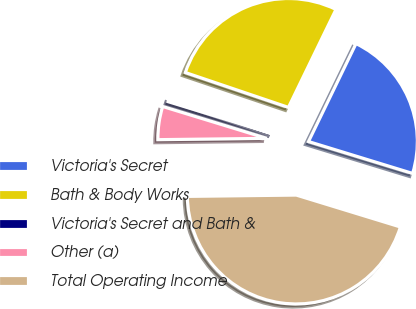Convert chart. <chart><loc_0><loc_0><loc_500><loc_500><pie_chart><fcel>Victoria's Secret<fcel>Bath & Body Works<fcel>Victoria's Secret and Bath &<fcel>Other (a)<fcel>Total Operating Income<nl><fcel>22.54%<fcel>27.0%<fcel>0.46%<fcel>4.92%<fcel>45.08%<nl></chart> 